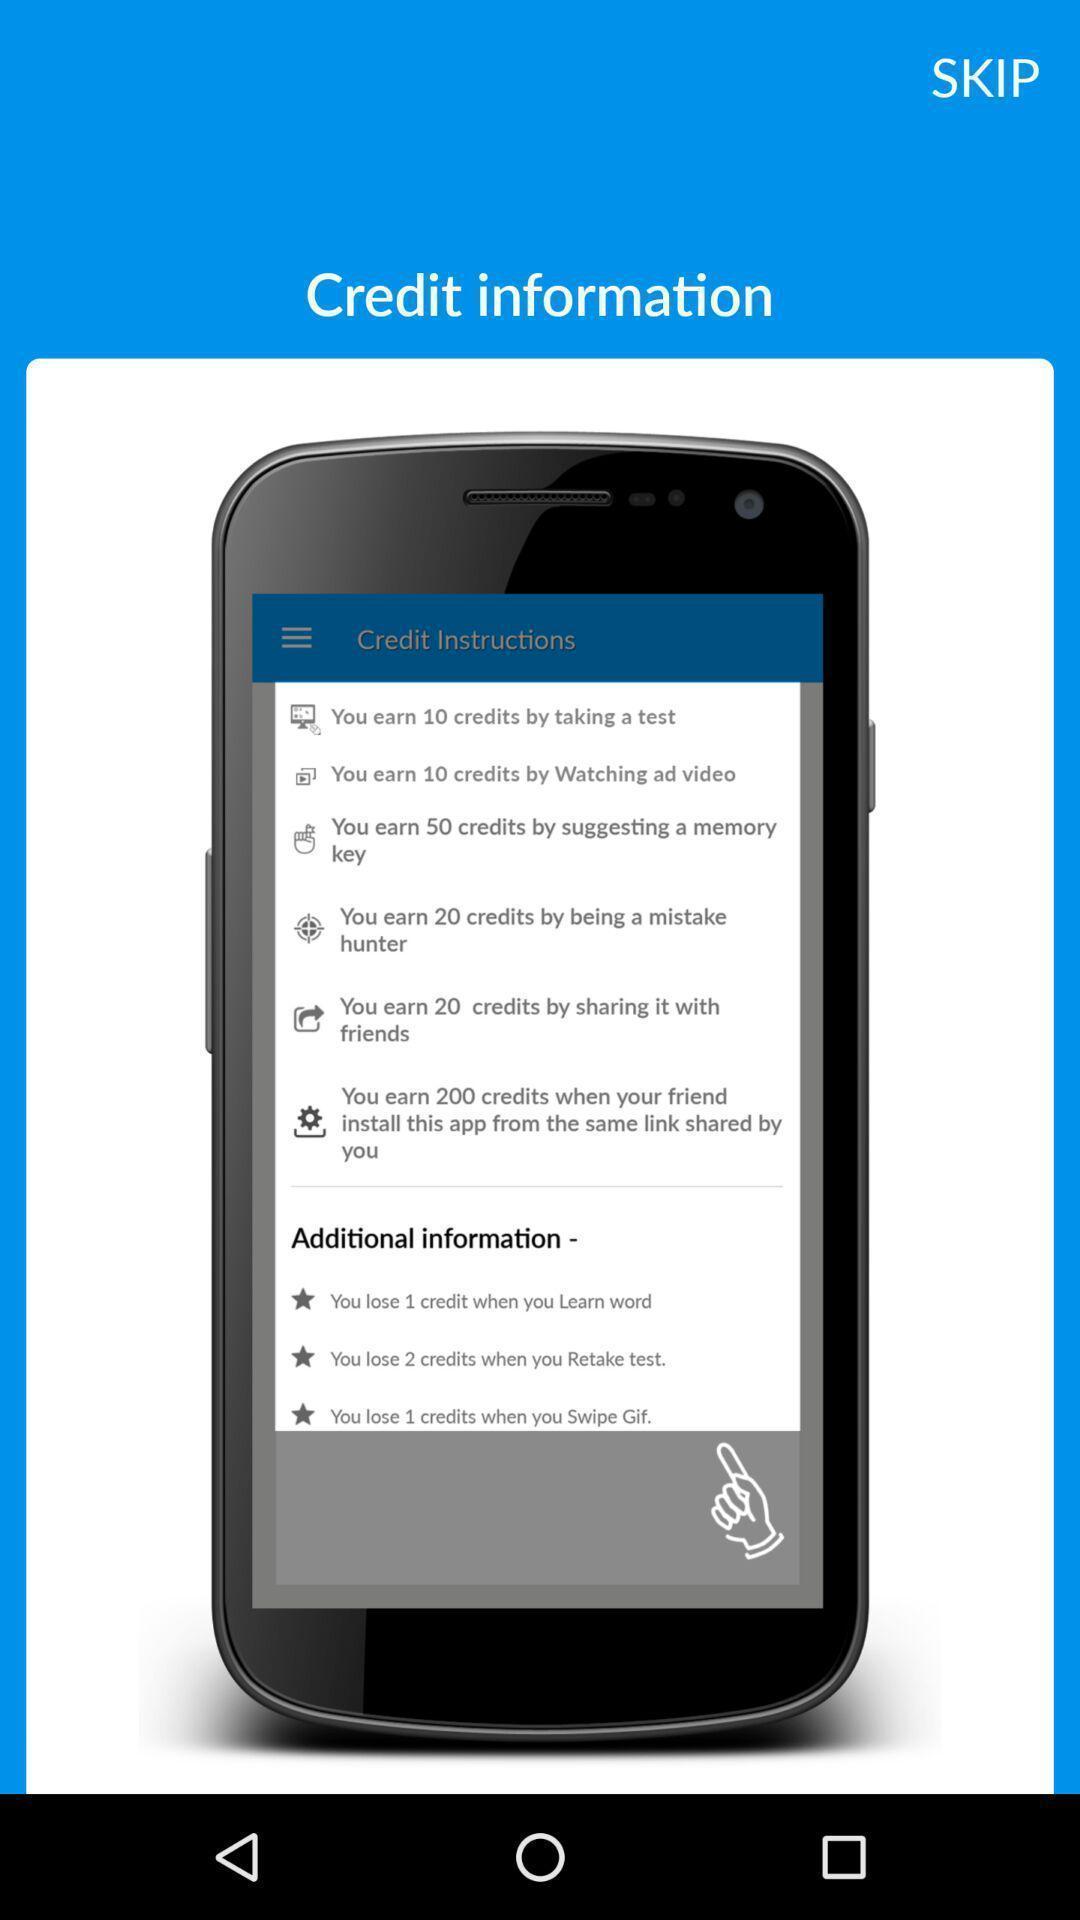Tell me about the visual elements in this screen capture. Screen displaying about credit information. 